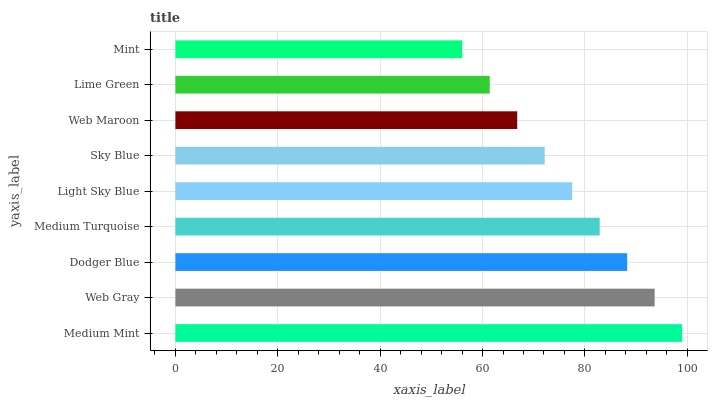Is Mint the minimum?
Answer yes or no. Yes. Is Medium Mint the maximum?
Answer yes or no. Yes. Is Web Gray the minimum?
Answer yes or no. No. Is Web Gray the maximum?
Answer yes or no. No. Is Medium Mint greater than Web Gray?
Answer yes or no. Yes. Is Web Gray less than Medium Mint?
Answer yes or no. Yes. Is Web Gray greater than Medium Mint?
Answer yes or no. No. Is Medium Mint less than Web Gray?
Answer yes or no. No. Is Light Sky Blue the high median?
Answer yes or no. Yes. Is Light Sky Blue the low median?
Answer yes or no. Yes. Is Medium Mint the high median?
Answer yes or no. No. Is Medium Turquoise the low median?
Answer yes or no. No. 